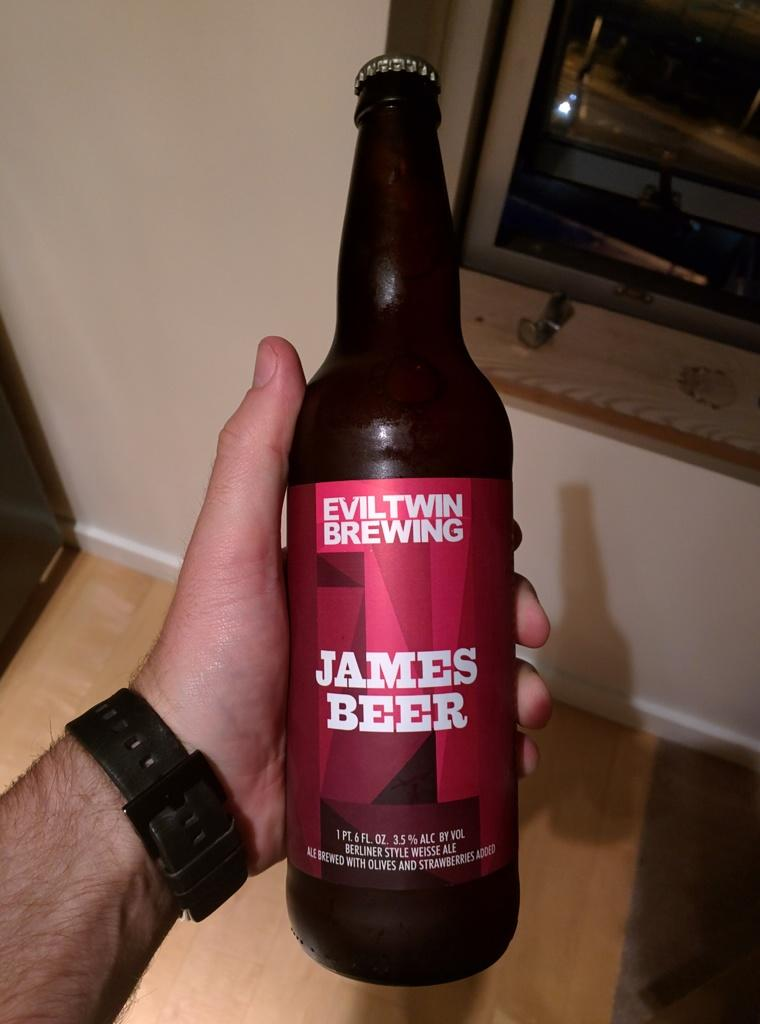<image>
Give a short and clear explanation of the subsequent image. a person is holding a bottle of James Beer 